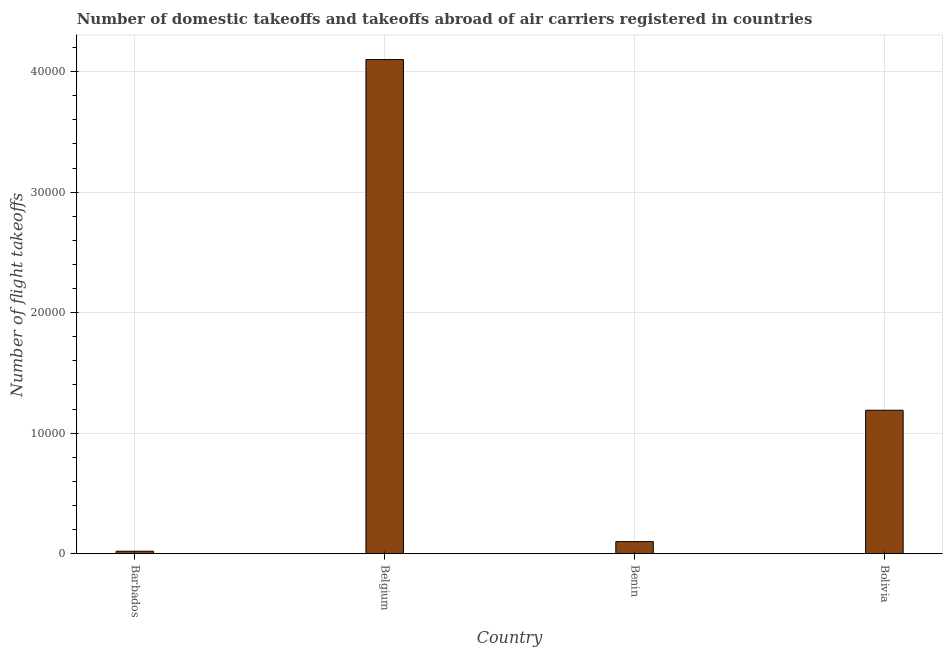What is the title of the graph?
Your answer should be very brief. Number of domestic takeoffs and takeoffs abroad of air carriers registered in countries. What is the label or title of the X-axis?
Provide a short and direct response. Country. What is the label or title of the Y-axis?
Provide a short and direct response. Number of flight takeoffs. What is the number of flight takeoffs in Bolivia?
Your response must be concise. 1.19e+04. Across all countries, what is the maximum number of flight takeoffs?
Keep it short and to the point. 4.10e+04. In which country was the number of flight takeoffs minimum?
Provide a short and direct response. Barbados. What is the sum of the number of flight takeoffs?
Offer a terse response. 5.41e+04. What is the difference between the number of flight takeoffs in Barbados and Belgium?
Provide a short and direct response. -4.08e+04. What is the average number of flight takeoffs per country?
Give a very brief answer. 1.35e+04. What is the median number of flight takeoffs?
Your response must be concise. 6450. What is the ratio of the number of flight takeoffs in Belgium to that in Benin?
Make the answer very short. 41. Is the number of flight takeoffs in Belgium less than that in Benin?
Your answer should be very brief. No. What is the difference between the highest and the second highest number of flight takeoffs?
Provide a short and direct response. 2.91e+04. What is the difference between the highest and the lowest number of flight takeoffs?
Your answer should be very brief. 4.08e+04. In how many countries, is the number of flight takeoffs greater than the average number of flight takeoffs taken over all countries?
Offer a very short reply. 1. What is the Number of flight takeoffs of Belgium?
Offer a very short reply. 4.10e+04. What is the Number of flight takeoffs of Bolivia?
Offer a very short reply. 1.19e+04. What is the difference between the Number of flight takeoffs in Barbados and Belgium?
Provide a succinct answer. -4.08e+04. What is the difference between the Number of flight takeoffs in Barbados and Benin?
Keep it short and to the point. -800. What is the difference between the Number of flight takeoffs in Barbados and Bolivia?
Keep it short and to the point. -1.17e+04. What is the difference between the Number of flight takeoffs in Belgium and Benin?
Offer a terse response. 4.00e+04. What is the difference between the Number of flight takeoffs in Belgium and Bolivia?
Offer a terse response. 2.91e+04. What is the difference between the Number of flight takeoffs in Benin and Bolivia?
Ensure brevity in your answer.  -1.09e+04. What is the ratio of the Number of flight takeoffs in Barbados to that in Belgium?
Your answer should be compact. 0.01. What is the ratio of the Number of flight takeoffs in Barbados to that in Bolivia?
Your response must be concise. 0.02. What is the ratio of the Number of flight takeoffs in Belgium to that in Benin?
Keep it short and to the point. 41. What is the ratio of the Number of flight takeoffs in Belgium to that in Bolivia?
Provide a short and direct response. 3.44. What is the ratio of the Number of flight takeoffs in Benin to that in Bolivia?
Offer a terse response. 0.08. 